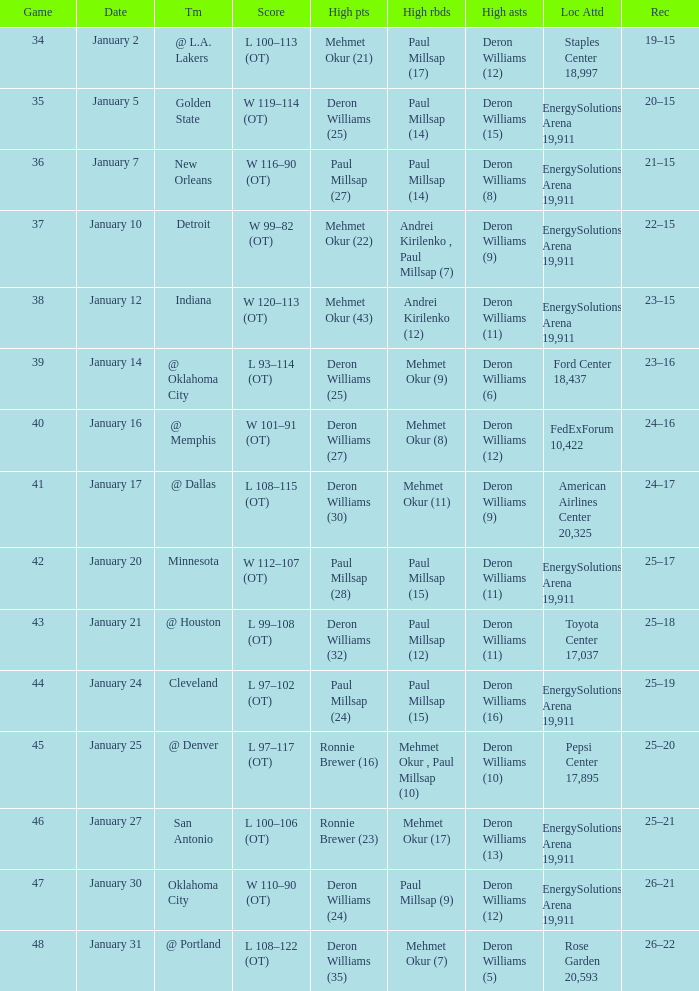What was the score of Game 48? L 108–122 (OT). 